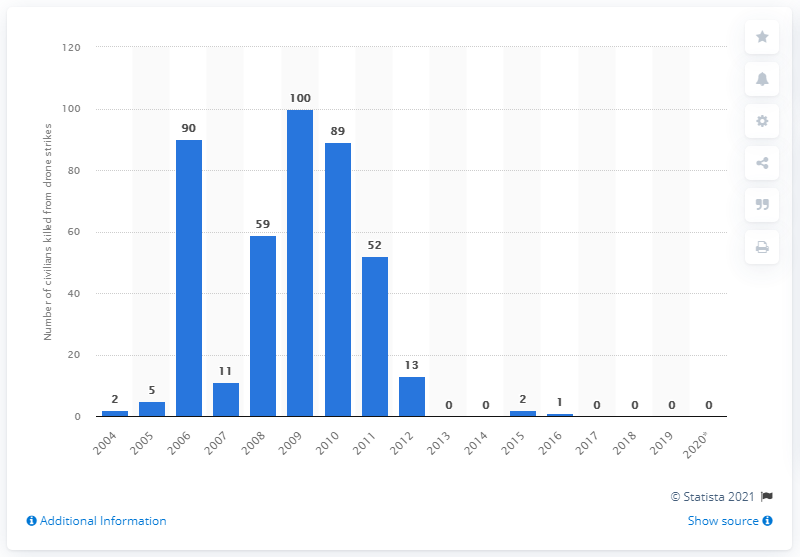List a handful of essential elements in this visual. In 2019, there were no reported drone strikes carried out by the U.S. in Pakistan. 